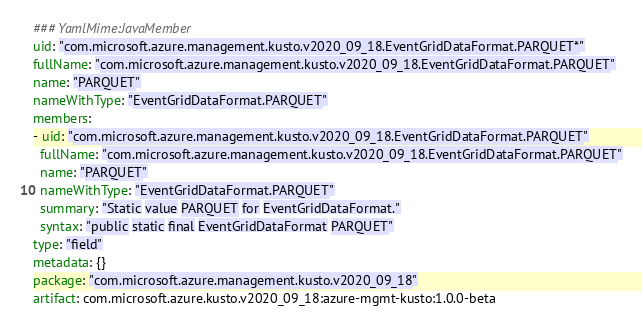Convert code to text. <code><loc_0><loc_0><loc_500><loc_500><_YAML_>### YamlMime:JavaMember
uid: "com.microsoft.azure.management.kusto.v2020_09_18.EventGridDataFormat.PARQUET*"
fullName: "com.microsoft.azure.management.kusto.v2020_09_18.EventGridDataFormat.PARQUET"
name: "PARQUET"
nameWithType: "EventGridDataFormat.PARQUET"
members:
- uid: "com.microsoft.azure.management.kusto.v2020_09_18.EventGridDataFormat.PARQUET"
  fullName: "com.microsoft.azure.management.kusto.v2020_09_18.EventGridDataFormat.PARQUET"
  name: "PARQUET"
  nameWithType: "EventGridDataFormat.PARQUET"
  summary: "Static value PARQUET for EventGridDataFormat."
  syntax: "public static final EventGridDataFormat PARQUET"
type: "field"
metadata: {}
package: "com.microsoft.azure.management.kusto.v2020_09_18"
artifact: com.microsoft.azure.kusto.v2020_09_18:azure-mgmt-kusto:1.0.0-beta
</code> 